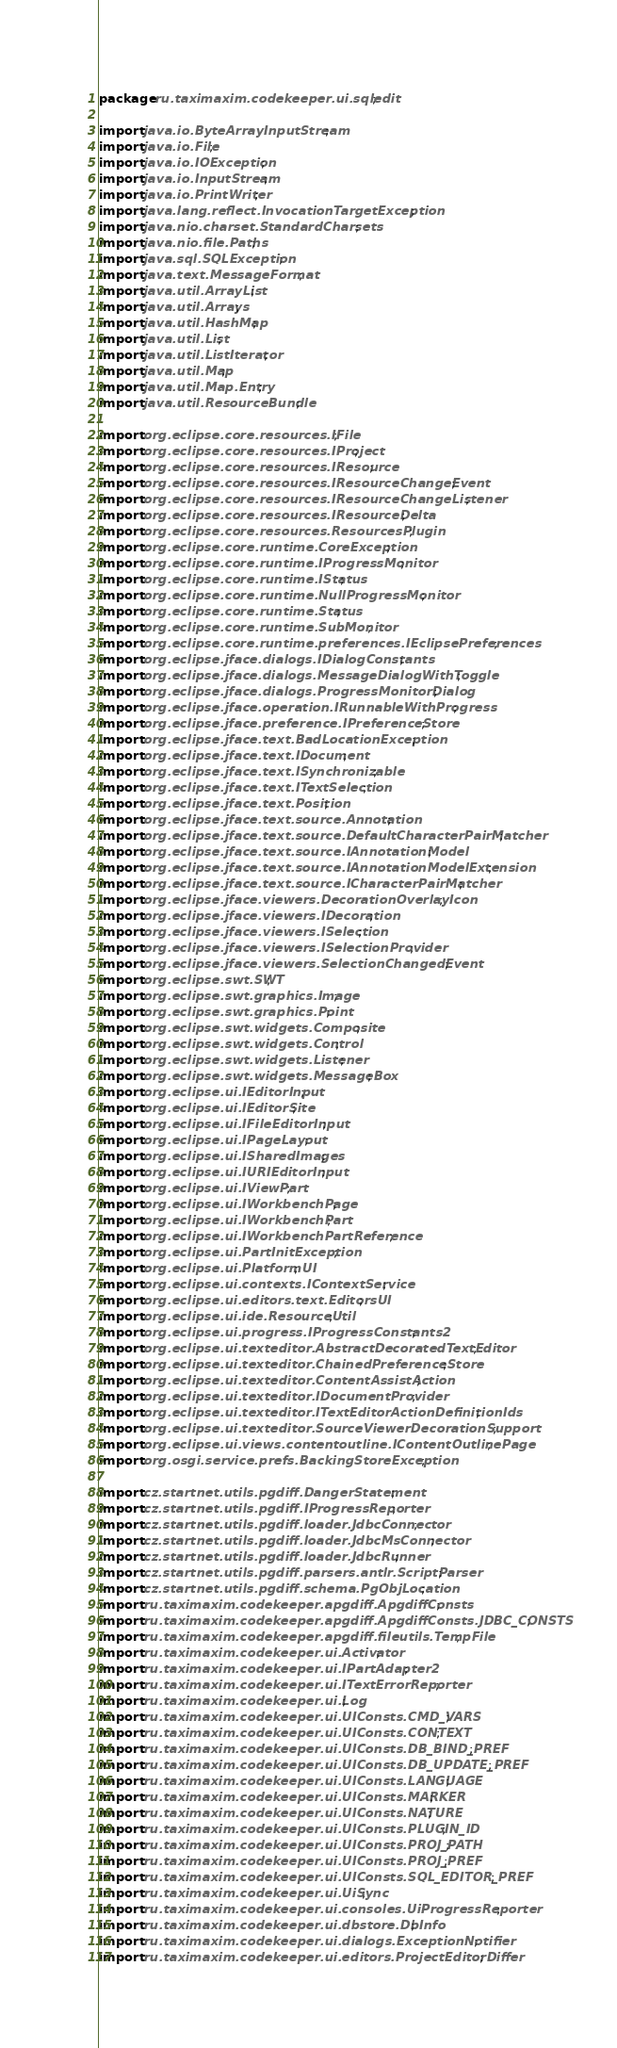<code> <loc_0><loc_0><loc_500><loc_500><_Java_>package ru.taximaxim.codekeeper.ui.sqledit;

import java.io.ByteArrayInputStream;
import java.io.File;
import java.io.IOException;
import java.io.InputStream;
import java.io.PrintWriter;
import java.lang.reflect.InvocationTargetException;
import java.nio.charset.StandardCharsets;
import java.nio.file.Paths;
import java.sql.SQLException;
import java.text.MessageFormat;
import java.util.ArrayList;
import java.util.Arrays;
import java.util.HashMap;
import java.util.List;
import java.util.ListIterator;
import java.util.Map;
import java.util.Map.Entry;
import java.util.ResourceBundle;

import org.eclipse.core.resources.IFile;
import org.eclipse.core.resources.IProject;
import org.eclipse.core.resources.IResource;
import org.eclipse.core.resources.IResourceChangeEvent;
import org.eclipse.core.resources.IResourceChangeListener;
import org.eclipse.core.resources.IResourceDelta;
import org.eclipse.core.resources.ResourcesPlugin;
import org.eclipse.core.runtime.CoreException;
import org.eclipse.core.runtime.IProgressMonitor;
import org.eclipse.core.runtime.IStatus;
import org.eclipse.core.runtime.NullProgressMonitor;
import org.eclipse.core.runtime.Status;
import org.eclipse.core.runtime.SubMonitor;
import org.eclipse.core.runtime.preferences.IEclipsePreferences;
import org.eclipse.jface.dialogs.IDialogConstants;
import org.eclipse.jface.dialogs.MessageDialogWithToggle;
import org.eclipse.jface.dialogs.ProgressMonitorDialog;
import org.eclipse.jface.operation.IRunnableWithProgress;
import org.eclipse.jface.preference.IPreferenceStore;
import org.eclipse.jface.text.BadLocationException;
import org.eclipse.jface.text.IDocument;
import org.eclipse.jface.text.ISynchronizable;
import org.eclipse.jface.text.ITextSelection;
import org.eclipse.jface.text.Position;
import org.eclipse.jface.text.source.Annotation;
import org.eclipse.jface.text.source.DefaultCharacterPairMatcher;
import org.eclipse.jface.text.source.IAnnotationModel;
import org.eclipse.jface.text.source.IAnnotationModelExtension;
import org.eclipse.jface.text.source.ICharacterPairMatcher;
import org.eclipse.jface.viewers.DecorationOverlayIcon;
import org.eclipse.jface.viewers.IDecoration;
import org.eclipse.jface.viewers.ISelection;
import org.eclipse.jface.viewers.ISelectionProvider;
import org.eclipse.jface.viewers.SelectionChangedEvent;
import org.eclipse.swt.SWT;
import org.eclipse.swt.graphics.Image;
import org.eclipse.swt.graphics.Point;
import org.eclipse.swt.widgets.Composite;
import org.eclipse.swt.widgets.Control;
import org.eclipse.swt.widgets.Listener;
import org.eclipse.swt.widgets.MessageBox;
import org.eclipse.ui.IEditorInput;
import org.eclipse.ui.IEditorSite;
import org.eclipse.ui.IFileEditorInput;
import org.eclipse.ui.IPageLayout;
import org.eclipse.ui.ISharedImages;
import org.eclipse.ui.IURIEditorInput;
import org.eclipse.ui.IViewPart;
import org.eclipse.ui.IWorkbenchPage;
import org.eclipse.ui.IWorkbenchPart;
import org.eclipse.ui.IWorkbenchPartReference;
import org.eclipse.ui.PartInitException;
import org.eclipse.ui.PlatformUI;
import org.eclipse.ui.contexts.IContextService;
import org.eclipse.ui.editors.text.EditorsUI;
import org.eclipse.ui.ide.ResourceUtil;
import org.eclipse.ui.progress.IProgressConstants2;
import org.eclipse.ui.texteditor.AbstractDecoratedTextEditor;
import org.eclipse.ui.texteditor.ChainedPreferenceStore;
import org.eclipse.ui.texteditor.ContentAssistAction;
import org.eclipse.ui.texteditor.IDocumentProvider;
import org.eclipse.ui.texteditor.ITextEditorActionDefinitionIds;
import org.eclipse.ui.texteditor.SourceViewerDecorationSupport;
import org.eclipse.ui.views.contentoutline.IContentOutlinePage;
import org.osgi.service.prefs.BackingStoreException;

import cz.startnet.utils.pgdiff.DangerStatement;
import cz.startnet.utils.pgdiff.IProgressReporter;
import cz.startnet.utils.pgdiff.loader.JdbcConnector;
import cz.startnet.utils.pgdiff.loader.JdbcMsConnector;
import cz.startnet.utils.pgdiff.loader.JdbcRunner;
import cz.startnet.utils.pgdiff.parsers.antlr.ScriptParser;
import cz.startnet.utils.pgdiff.schema.PgObjLocation;
import ru.taximaxim.codekeeper.apgdiff.ApgdiffConsts;
import ru.taximaxim.codekeeper.apgdiff.ApgdiffConsts.JDBC_CONSTS;
import ru.taximaxim.codekeeper.apgdiff.fileutils.TempFile;
import ru.taximaxim.codekeeper.ui.Activator;
import ru.taximaxim.codekeeper.ui.IPartAdapter2;
import ru.taximaxim.codekeeper.ui.ITextErrorReporter;
import ru.taximaxim.codekeeper.ui.Log;
import ru.taximaxim.codekeeper.ui.UIConsts.CMD_VARS;
import ru.taximaxim.codekeeper.ui.UIConsts.CONTEXT;
import ru.taximaxim.codekeeper.ui.UIConsts.DB_BIND_PREF;
import ru.taximaxim.codekeeper.ui.UIConsts.DB_UPDATE_PREF;
import ru.taximaxim.codekeeper.ui.UIConsts.LANGUAGE;
import ru.taximaxim.codekeeper.ui.UIConsts.MARKER;
import ru.taximaxim.codekeeper.ui.UIConsts.NATURE;
import ru.taximaxim.codekeeper.ui.UIConsts.PLUGIN_ID;
import ru.taximaxim.codekeeper.ui.UIConsts.PROJ_PATH;
import ru.taximaxim.codekeeper.ui.UIConsts.PROJ_PREF;
import ru.taximaxim.codekeeper.ui.UIConsts.SQL_EDITOR_PREF;
import ru.taximaxim.codekeeper.ui.UiSync;
import ru.taximaxim.codekeeper.ui.consoles.UiProgressReporter;
import ru.taximaxim.codekeeper.ui.dbstore.DbInfo;
import ru.taximaxim.codekeeper.ui.dialogs.ExceptionNotifier;
import ru.taximaxim.codekeeper.ui.editors.ProjectEditorDiffer;</code> 